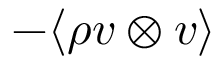<formula> <loc_0><loc_0><loc_500><loc_500>- \langle \rho v \otimes v \rangle</formula> 